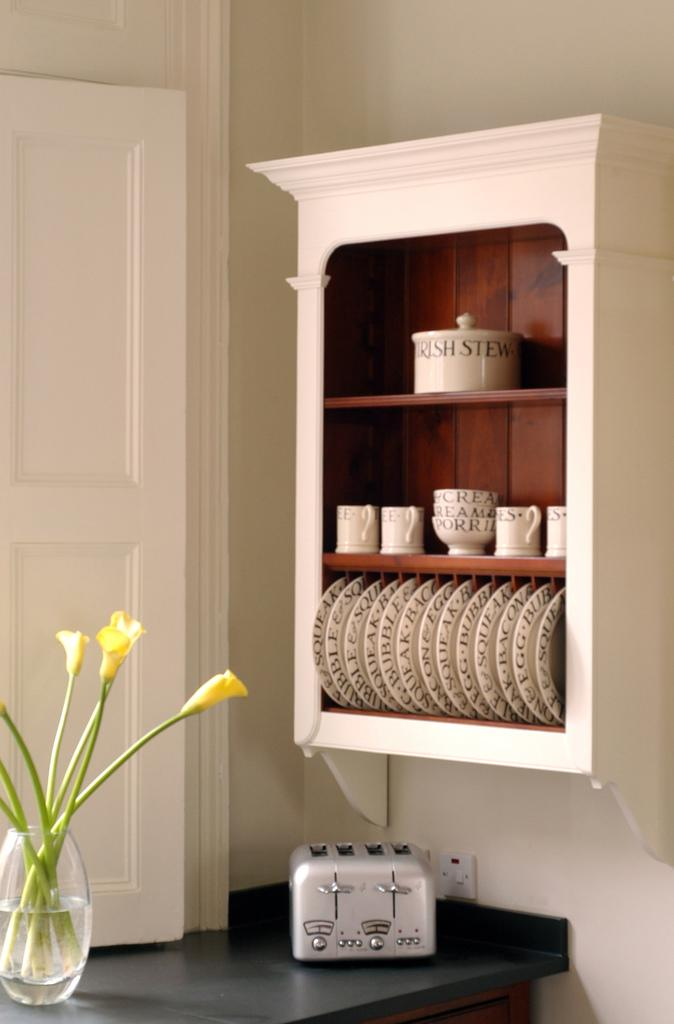<image>
Provide a brief description of the given image. Above a four slice, stainless steel toaster is a white cabinet, hanging on the wall, holding dinner ware with the names of specific dishes printed on them. 